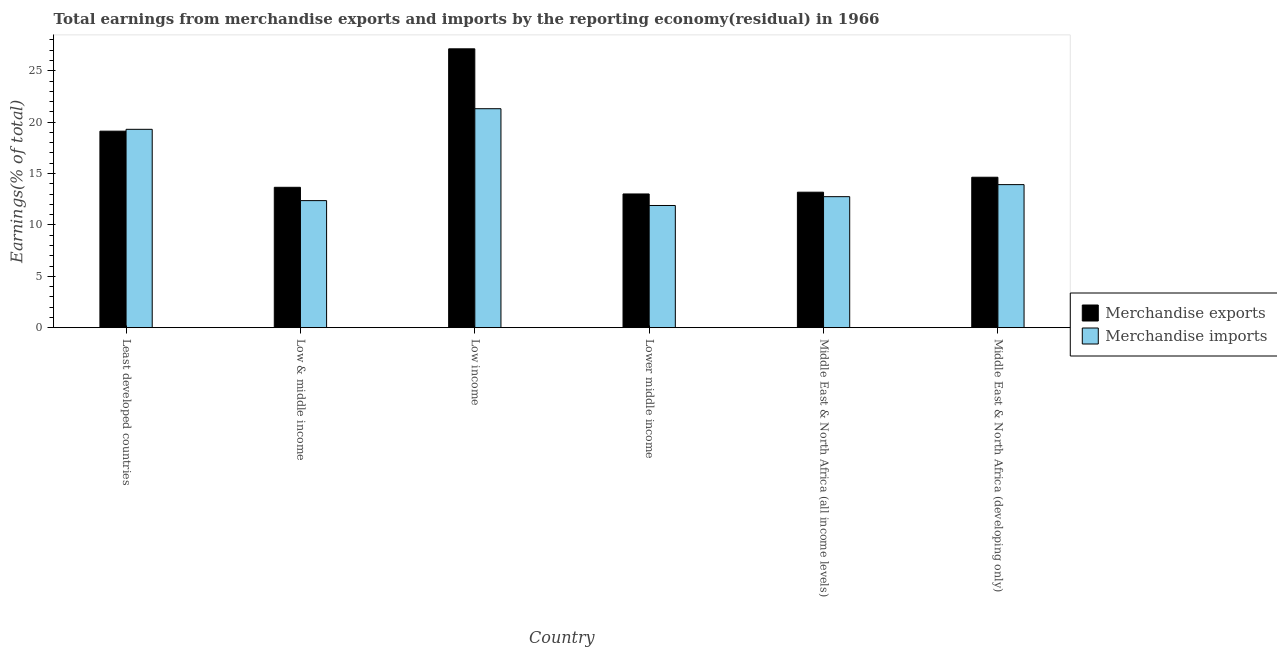How many different coloured bars are there?
Offer a very short reply. 2. Are the number of bars on each tick of the X-axis equal?
Provide a short and direct response. Yes. How many bars are there on the 6th tick from the left?
Make the answer very short. 2. How many bars are there on the 5th tick from the right?
Offer a very short reply. 2. What is the label of the 1st group of bars from the left?
Keep it short and to the point. Least developed countries. What is the earnings from merchandise imports in Middle East & North Africa (developing only)?
Offer a very short reply. 13.92. Across all countries, what is the maximum earnings from merchandise exports?
Provide a short and direct response. 27.13. Across all countries, what is the minimum earnings from merchandise imports?
Your answer should be very brief. 11.89. In which country was the earnings from merchandise imports minimum?
Provide a short and direct response. Lower middle income. What is the total earnings from merchandise imports in the graph?
Offer a very short reply. 91.52. What is the difference between the earnings from merchandise imports in Low income and that in Lower middle income?
Provide a succinct answer. 9.42. What is the difference between the earnings from merchandise exports in Middle East & North Africa (developing only) and the earnings from merchandise imports in Middle East & North Africa (all income levels)?
Offer a very short reply. 1.89. What is the average earnings from merchandise imports per country?
Give a very brief answer. 15.25. What is the difference between the earnings from merchandise exports and earnings from merchandise imports in Least developed countries?
Make the answer very short. -0.18. In how many countries, is the earnings from merchandise exports greater than 27 %?
Offer a terse response. 1. What is the ratio of the earnings from merchandise exports in Low & middle income to that in Low income?
Offer a terse response. 0.5. Is the earnings from merchandise imports in Least developed countries less than that in Lower middle income?
Provide a short and direct response. No. What is the difference between the highest and the second highest earnings from merchandise imports?
Your answer should be compact. 2. What is the difference between the highest and the lowest earnings from merchandise imports?
Your answer should be compact. 9.42. In how many countries, is the earnings from merchandise imports greater than the average earnings from merchandise imports taken over all countries?
Give a very brief answer. 2. Is the sum of the earnings from merchandise exports in Low & middle income and Middle East & North Africa (all income levels) greater than the maximum earnings from merchandise imports across all countries?
Provide a short and direct response. Yes. How many countries are there in the graph?
Give a very brief answer. 6. What is the difference between two consecutive major ticks on the Y-axis?
Your response must be concise. 5. Are the values on the major ticks of Y-axis written in scientific E-notation?
Ensure brevity in your answer.  No. How many legend labels are there?
Provide a succinct answer. 2. How are the legend labels stacked?
Give a very brief answer. Vertical. What is the title of the graph?
Your answer should be compact. Total earnings from merchandise exports and imports by the reporting economy(residual) in 1966. What is the label or title of the X-axis?
Give a very brief answer. Country. What is the label or title of the Y-axis?
Give a very brief answer. Earnings(% of total). What is the Earnings(% of total) in Merchandise exports in Least developed countries?
Provide a short and direct response. 19.12. What is the Earnings(% of total) of Merchandise imports in Least developed countries?
Make the answer very short. 19.3. What is the Earnings(% of total) in Merchandise exports in Low & middle income?
Your answer should be very brief. 13.66. What is the Earnings(% of total) of Merchandise imports in Low & middle income?
Give a very brief answer. 12.36. What is the Earnings(% of total) of Merchandise exports in Low income?
Give a very brief answer. 27.13. What is the Earnings(% of total) in Merchandise imports in Low income?
Provide a short and direct response. 21.31. What is the Earnings(% of total) in Merchandise exports in Lower middle income?
Keep it short and to the point. 13.01. What is the Earnings(% of total) in Merchandise imports in Lower middle income?
Your answer should be very brief. 11.89. What is the Earnings(% of total) in Merchandise exports in Middle East & North Africa (all income levels)?
Offer a very short reply. 13.18. What is the Earnings(% of total) in Merchandise imports in Middle East & North Africa (all income levels)?
Your response must be concise. 12.75. What is the Earnings(% of total) in Merchandise exports in Middle East & North Africa (developing only)?
Offer a very short reply. 14.64. What is the Earnings(% of total) of Merchandise imports in Middle East & North Africa (developing only)?
Provide a succinct answer. 13.92. Across all countries, what is the maximum Earnings(% of total) of Merchandise exports?
Your answer should be compact. 27.13. Across all countries, what is the maximum Earnings(% of total) of Merchandise imports?
Ensure brevity in your answer.  21.31. Across all countries, what is the minimum Earnings(% of total) in Merchandise exports?
Keep it short and to the point. 13.01. Across all countries, what is the minimum Earnings(% of total) in Merchandise imports?
Your response must be concise. 11.89. What is the total Earnings(% of total) in Merchandise exports in the graph?
Make the answer very short. 100.74. What is the total Earnings(% of total) in Merchandise imports in the graph?
Your answer should be compact. 91.52. What is the difference between the Earnings(% of total) of Merchandise exports in Least developed countries and that in Low & middle income?
Your answer should be compact. 5.46. What is the difference between the Earnings(% of total) of Merchandise imports in Least developed countries and that in Low & middle income?
Provide a succinct answer. 6.94. What is the difference between the Earnings(% of total) of Merchandise exports in Least developed countries and that in Low income?
Give a very brief answer. -8.01. What is the difference between the Earnings(% of total) in Merchandise imports in Least developed countries and that in Low income?
Your response must be concise. -2. What is the difference between the Earnings(% of total) in Merchandise exports in Least developed countries and that in Lower middle income?
Ensure brevity in your answer.  6.11. What is the difference between the Earnings(% of total) in Merchandise imports in Least developed countries and that in Lower middle income?
Give a very brief answer. 7.41. What is the difference between the Earnings(% of total) of Merchandise exports in Least developed countries and that in Middle East & North Africa (all income levels)?
Provide a short and direct response. 5.94. What is the difference between the Earnings(% of total) of Merchandise imports in Least developed countries and that in Middle East & North Africa (all income levels)?
Ensure brevity in your answer.  6.55. What is the difference between the Earnings(% of total) of Merchandise exports in Least developed countries and that in Middle East & North Africa (developing only)?
Give a very brief answer. 4.48. What is the difference between the Earnings(% of total) in Merchandise imports in Least developed countries and that in Middle East & North Africa (developing only)?
Provide a short and direct response. 5.38. What is the difference between the Earnings(% of total) in Merchandise exports in Low & middle income and that in Low income?
Provide a short and direct response. -13.48. What is the difference between the Earnings(% of total) in Merchandise imports in Low & middle income and that in Low income?
Provide a succinct answer. -8.94. What is the difference between the Earnings(% of total) of Merchandise exports in Low & middle income and that in Lower middle income?
Your answer should be compact. 0.65. What is the difference between the Earnings(% of total) of Merchandise imports in Low & middle income and that in Lower middle income?
Make the answer very short. 0.47. What is the difference between the Earnings(% of total) in Merchandise exports in Low & middle income and that in Middle East & North Africa (all income levels)?
Your answer should be compact. 0.48. What is the difference between the Earnings(% of total) of Merchandise imports in Low & middle income and that in Middle East & North Africa (all income levels)?
Your response must be concise. -0.38. What is the difference between the Earnings(% of total) in Merchandise exports in Low & middle income and that in Middle East & North Africa (developing only)?
Your answer should be very brief. -0.98. What is the difference between the Earnings(% of total) of Merchandise imports in Low & middle income and that in Middle East & North Africa (developing only)?
Ensure brevity in your answer.  -1.56. What is the difference between the Earnings(% of total) of Merchandise exports in Low income and that in Lower middle income?
Offer a very short reply. 14.12. What is the difference between the Earnings(% of total) in Merchandise imports in Low income and that in Lower middle income?
Your answer should be compact. 9.42. What is the difference between the Earnings(% of total) in Merchandise exports in Low income and that in Middle East & North Africa (all income levels)?
Provide a succinct answer. 13.95. What is the difference between the Earnings(% of total) in Merchandise imports in Low income and that in Middle East & North Africa (all income levels)?
Provide a short and direct response. 8.56. What is the difference between the Earnings(% of total) in Merchandise exports in Low income and that in Middle East & North Africa (developing only)?
Keep it short and to the point. 12.5. What is the difference between the Earnings(% of total) of Merchandise imports in Low income and that in Middle East & North Africa (developing only)?
Your response must be concise. 7.39. What is the difference between the Earnings(% of total) in Merchandise exports in Lower middle income and that in Middle East & North Africa (all income levels)?
Your answer should be compact. -0.17. What is the difference between the Earnings(% of total) in Merchandise imports in Lower middle income and that in Middle East & North Africa (all income levels)?
Provide a succinct answer. -0.86. What is the difference between the Earnings(% of total) of Merchandise exports in Lower middle income and that in Middle East & North Africa (developing only)?
Offer a very short reply. -1.63. What is the difference between the Earnings(% of total) in Merchandise imports in Lower middle income and that in Middle East & North Africa (developing only)?
Keep it short and to the point. -2.03. What is the difference between the Earnings(% of total) of Merchandise exports in Middle East & North Africa (all income levels) and that in Middle East & North Africa (developing only)?
Your response must be concise. -1.45. What is the difference between the Earnings(% of total) in Merchandise imports in Middle East & North Africa (all income levels) and that in Middle East & North Africa (developing only)?
Offer a very short reply. -1.17. What is the difference between the Earnings(% of total) of Merchandise exports in Least developed countries and the Earnings(% of total) of Merchandise imports in Low & middle income?
Give a very brief answer. 6.76. What is the difference between the Earnings(% of total) in Merchandise exports in Least developed countries and the Earnings(% of total) in Merchandise imports in Low income?
Make the answer very short. -2.18. What is the difference between the Earnings(% of total) of Merchandise exports in Least developed countries and the Earnings(% of total) of Merchandise imports in Lower middle income?
Ensure brevity in your answer.  7.23. What is the difference between the Earnings(% of total) in Merchandise exports in Least developed countries and the Earnings(% of total) in Merchandise imports in Middle East & North Africa (all income levels)?
Give a very brief answer. 6.37. What is the difference between the Earnings(% of total) of Merchandise exports in Least developed countries and the Earnings(% of total) of Merchandise imports in Middle East & North Africa (developing only)?
Ensure brevity in your answer.  5.2. What is the difference between the Earnings(% of total) in Merchandise exports in Low & middle income and the Earnings(% of total) in Merchandise imports in Low income?
Offer a very short reply. -7.65. What is the difference between the Earnings(% of total) of Merchandise exports in Low & middle income and the Earnings(% of total) of Merchandise imports in Lower middle income?
Offer a very short reply. 1.77. What is the difference between the Earnings(% of total) in Merchandise exports in Low & middle income and the Earnings(% of total) in Merchandise imports in Middle East & North Africa (all income levels)?
Offer a very short reply. 0.91. What is the difference between the Earnings(% of total) in Merchandise exports in Low & middle income and the Earnings(% of total) in Merchandise imports in Middle East & North Africa (developing only)?
Ensure brevity in your answer.  -0.26. What is the difference between the Earnings(% of total) in Merchandise exports in Low income and the Earnings(% of total) in Merchandise imports in Lower middle income?
Make the answer very short. 15.24. What is the difference between the Earnings(% of total) in Merchandise exports in Low income and the Earnings(% of total) in Merchandise imports in Middle East & North Africa (all income levels)?
Provide a succinct answer. 14.39. What is the difference between the Earnings(% of total) in Merchandise exports in Low income and the Earnings(% of total) in Merchandise imports in Middle East & North Africa (developing only)?
Make the answer very short. 13.21. What is the difference between the Earnings(% of total) of Merchandise exports in Lower middle income and the Earnings(% of total) of Merchandise imports in Middle East & North Africa (all income levels)?
Keep it short and to the point. 0.26. What is the difference between the Earnings(% of total) in Merchandise exports in Lower middle income and the Earnings(% of total) in Merchandise imports in Middle East & North Africa (developing only)?
Offer a very short reply. -0.91. What is the difference between the Earnings(% of total) in Merchandise exports in Middle East & North Africa (all income levels) and the Earnings(% of total) in Merchandise imports in Middle East & North Africa (developing only)?
Ensure brevity in your answer.  -0.74. What is the average Earnings(% of total) of Merchandise exports per country?
Your response must be concise. 16.79. What is the average Earnings(% of total) of Merchandise imports per country?
Your answer should be compact. 15.25. What is the difference between the Earnings(% of total) of Merchandise exports and Earnings(% of total) of Merchandise imports in Least developed countries?
Your answer should be very brief. -0.18. What is the difference between the Earnings(% of total) in Merchandise exports and Earnings(% of total) in Merchandise imports in Low & middle income?
Your answer should be very brief. 1.3. What is the difference between the Earnings(% of total) in Merchandise exports and Earnings(% of total) in Merchandise imports in Low income?
Ensure brevity in your answer.  5.83. What is the difference between the Earnings(% of total) of Merchandise exports and Earnings(% of total) of Merchandise imports in Lower middle income?
Ensure brevity in your answer.  1.12. What is the difference between the Earnings(% of total) in Merchandise exports and Earnings(% of total) in Merchandise imports in Middle East & North Africa (all income levels)?
Your answer should be compact. 0.44. What is the difference between the Earnings(% of total) of Merchandise exports and Earnings(% of total) of Merchandise imports in Middle East & North Africa (developing only)?
Your answer should be very brief. 0.72. What is the ratio of the Earnings(% of total) of Merchandise imports in Least developed countries to that in Low & middle income?
Your response must be concise. 1.56. What is the ratio of the Earnings(% of total) of Merchandise exports in Least developed countries to that in Low income?
Provide a succinct answer. 0.7. What is the ratio of the Earnings(% of total) in Merchandise imports in Least developed countries to that in Low income?
Ensure brevity in your answer.  0.91. What is the ratio of the Earnings(% of total) in Merchandise exports in Least developed countries to that in Lower middle income?
Ensure brevity in your answer.  1.47. What is the ratio of the Earnings(% of total) in Merchandise imports in Least developed countries to that in Lower middle income?
Offer a terse response. 1.62. What is the ratio of the Earnings(% of total) of Merchandise exports in Least developed countries to that in Middle East & North Africa (all income levels)?
Provide a short and direct response. 1.45. What is the ratio of the Earnings(% of total) of Merchandise imports in Least developed countries to that in Middle East & North Africa (all income levels)?
Keep it short and to the point. 1.51. What is the ratio of the Earnings(% of total) of Merchandise exports in Least developed countries to that in Middle East & North Africa (developing only)?
Your answer should be compact. 1.31. What is the ratio of the Earnings(% of total) of Merchandise imports in Least developed countries to that in Middle East & North Africa (developing only)?
Provide a succinct answer. 1.39. What is the ratio of the Earnings(% of total) of Merchandise exports in Low & middle income to that in Low income?
Provide a succinct answer. 0.5. What is the ratio of the Earnings(% of total) of Merchandise imports in Low & middle income to that in Low income?
Offer a very short reply. 0.58. What is the ratio of the Earnings(% of total) in Merchandise exports in Low & middle income to that in Lower middle income?
Offer a terse response. 1.05. What is the ratio of the Earnings(% of total) of Merchandise imports in Low & middle income to that in Lower middle income?
Ensure brevity in your answer.  1.04. What is the ratio of the Earnings(% of total) in Merchandise exports in Low & middle income to that in Middle East & North Africa (all income levels)?
Offer a very short reply. 1.04. What is the ratio of the Earnings(% of total) in Merchandise imports in Low & middle income to that in Middle East & North Africa (all income levels)?
Your answer should be compact. 0.97. What is the ratio of the Earnings(% of total) of Merchandise exports in Low & middle income to that in Middle East & North Africa (developing only)?
Provide a succinct answer. 0.93. What is the ratio of the Earnings(% of total) in Merchandise imports in Low & middle income to that in Middle East & North Africa (developing only)?
Keep it short and to the point. 0.89. What is the ratio of the Earnings(% of total) of Merchandise exports in Low income to that in Lower middle income?
Your answer should be compact. 2.09. What is the ratio of the Earnings(% of total) of Merchandise imports in Low income to that in Lower middle income?
Keep it short and to the point. 1.79. What is the ratio of the Earnings(% of total) in Merchandise exports in Low income to that in Middle East & North Africa (all income levels)?
Offer a terse response. 2.06. What is the ratio of the Earnings(% of total) in Merchandise imports in Low income to that in Middle East & North Africa (all income levels)?
Offer a very short reply. 1.67. What is the ratio of the Earnings(% of total) of Merchandise exports in Low income to that in Middle East & North Africa (developing only)?
Your response must be concise. 1.85. What is the ratio of the Earnings(% of total) in Merchandise imports in Low income to that in Middle East & North Africa (developing only)?
Offer a terse response. 1.53. What is the ratio of the Earnings(% of total) of Merchandise exports in Lower middle income to that in Middle East & North Africa (all income levels)?
Your response must be concise. 0.99. What is the ratio of the Earnings(% of total) in Merchandise imports in Lower middle income to that in Middle East & North Africa (all income levels)?
Your answer should be very brief. 0.93. What is the ratio of the Earnings(% of total) of Merchandise exports in Lower middle income to that in Middle East & North Africa (developing only)?
Ensure brevity in your answer.  0.89. What is the ratio of the Earnings(% of total) in Merchandise imports in Lower middle income to that in Middle East & North Africa (developing only)?
Offer a very short reply. 0.85. What is the ratio of the Earnings(% of total) in Merchandise exports in Middle East & North Africa (all income levels) to that in Middle East & North Africa (developing only)?
Give a very brief answer. 0.9. What is the ratio of the Earnings(% of total) of Merchandise imports in Middle East & North Africa (all income levels) to that in Middle East & North Africa (developing only)?
Give a very brief answer. 0.92. What is the difference between the highest and the second highest Earnings(% of total) of Merchandise exports?
Offer a very short reply. 8.01. What is the difference between the highest and the second highest Earnings(% of total) of Merchandise imports?
Offer a terse response. 2. What is the difference between the highest and the lowest Earnings(% of total) of Merchandise exports?
Provide a short and direct response. 14.12. What is the difference between the highest and the lowest Earnings(% of total) of Merchandise imports?
Your response must be concise. 9.42. 